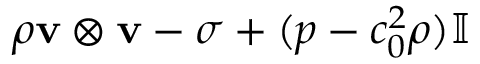Convert formula to latex. <formula><loc_0><loc_0><loc_500><loc_500>\rho v \otimes v - \sigma + ( p - c _ { 0 } ^ { 2 } \rho ) \mathbb { I }</formula> 